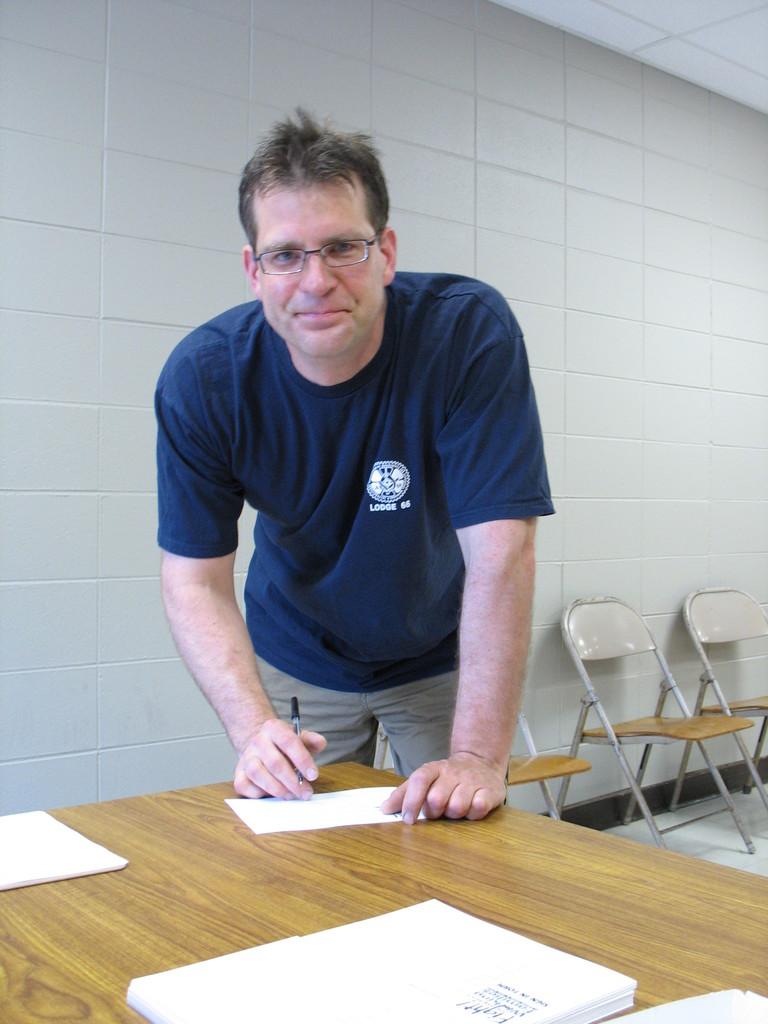What is the lodge number?
Provide a short and direct response. 66. He belongs to what 66?
Provide a short and direct response. Lodge. 